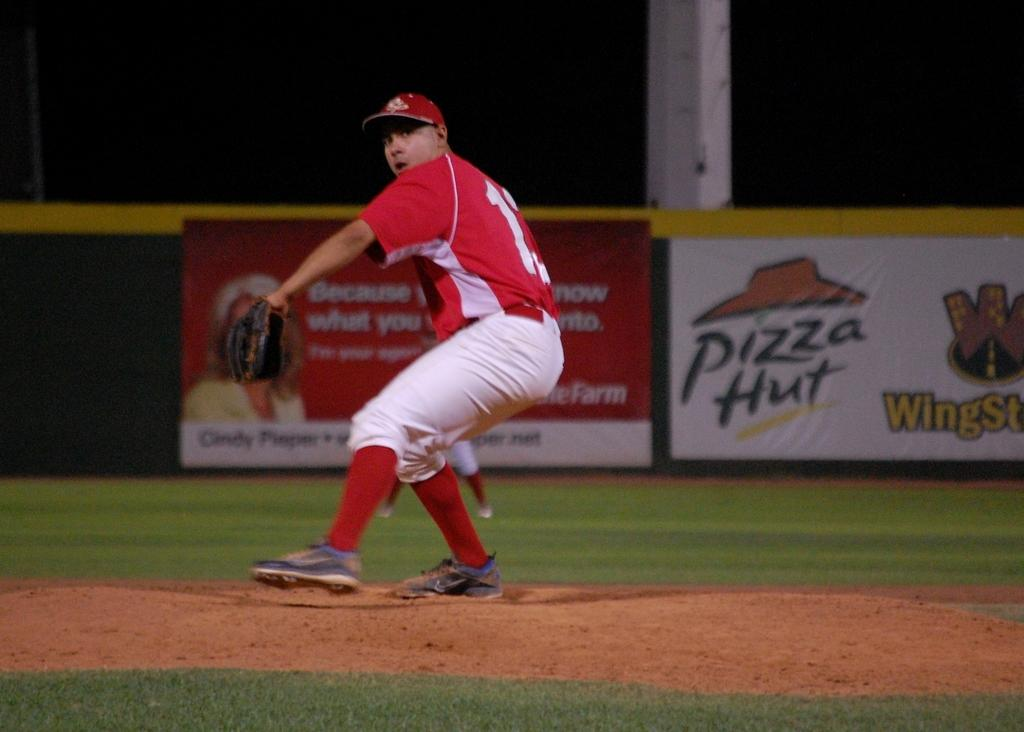<image>
Provide a brief description of the given image. A man in a red and white baseball uniform stands in front of an advertisement for Pizza Hut. 